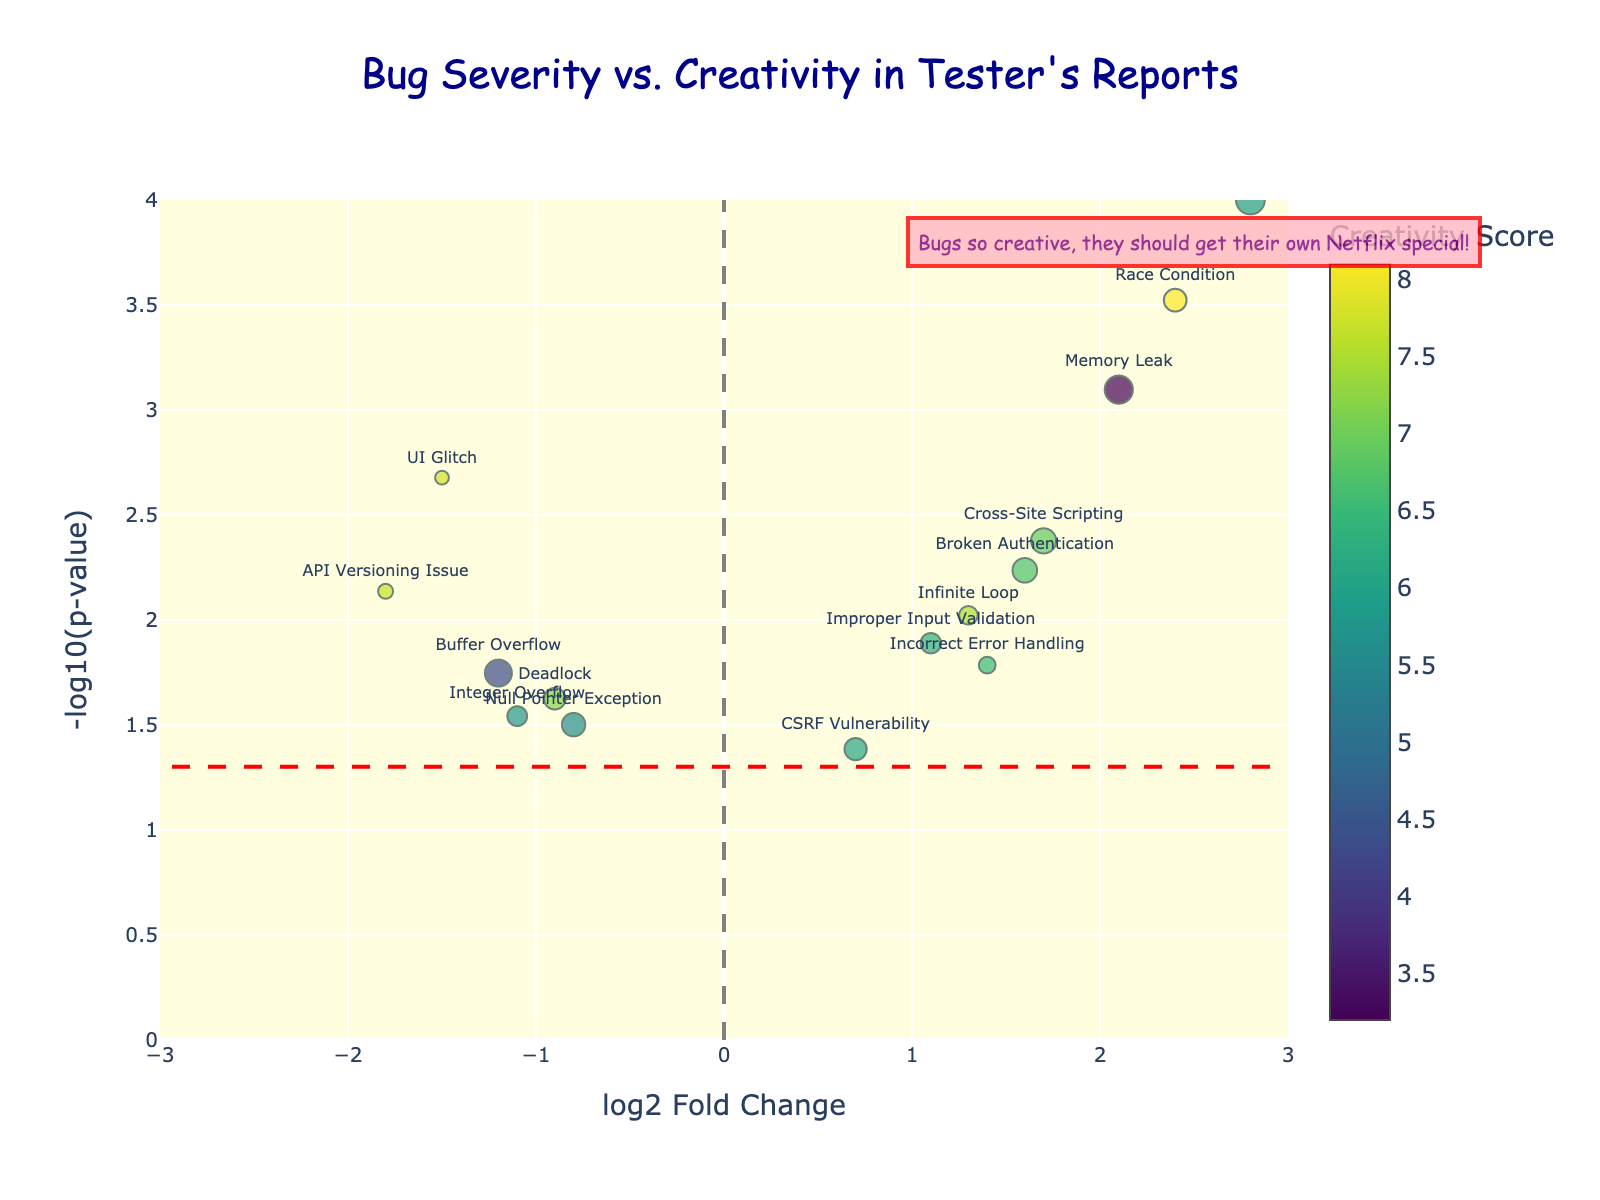What is the title of the plot? The title of the plot is displayed prominently at the top of the figure which reads "Bug Severity vs. Creativity in Tester's Reports".
Answer: "Bug Severity vs. Creativity in Tester's Reports" What do the axes represent in this plot? The x-axis represents the log2 Fold Change of the bugs, and the y-axis represents the -log10(p-value). This is typical for a volcano plot, where the x-axis shows the measure of change (positive or negative) and the y-axis indicates statistical significance (lower p-value means higher).
Answer: x-axis: log2 Fold Change, y-axis: -log10(p-value) Which bug type has the highest severity score? From the plot, we can see that SQL Injection has the highest severity score because its marker size is the largest among all the data points. The severity score influences the size of the markers, and SQL Injection is the largest.
Answer: SQL Injection Which bug type has the highest creativity score? By looking at the color scale provided in the plot, the darkest color indicates the highest creativity score. Race Condition has the darkest color and therefore the highest creativity score.
Answer: Race Condition How many bug types have a log2FoldChange greater than 0? To find this, count the data points to the right side of the y-axis (log2FoldChange > 0). These points are Memory Leak, Cross-Site Scripting, Race Condition, SQL Injection, Broken Authentication, Incorrect Error Handling, and Improper Input Validation. There are 7 bug types in total.
Answer: 7 Which bug type is the least significant, based on p-value? The y-axis represents -log10(p-value), so the lower the value, the less significant it is. The point with the lowest y-value (towards the bottom) corresponds to CSRF Vulnerability, indicating it has the highest p-value, thus the least significance.
Answer: CSRF Vulnerability What is the significance threshold value in this plot? The significance threshold is represented by a dashed red horizontal line. The y-value of this line indicates the threshold, which is -log10(0.05) ≈ 1.3.
Answer: 1.3 Which bug type crossed both the significance threshold and has a positive log2FoldChange? To find this, look for data points above the red dashed line (significance threshold) and to the right of the y-axis (positive log2FoldChange). SQL Injection is such a point.
Answer: SQL Injection From the plot, which bug types have negative log2FoldChange and also above significance threshold? Check for data points above the significance threshold (red dashed line) and to the left of the y-axis (negative log2FoldChange). The UI Glitch is such a point.
Answer: UI Glitch Which bug types are annotated with humorous text, and what is the text? The annotation in the plot is located near the top right, next to data points with high creativity scores and log2FoldChange. The humorous text "Bugs so creative, they should get their own Netflix special!" is added specifically for this purpose.
Answer: "Bugs so creative, they should get their own Netflix special!" 